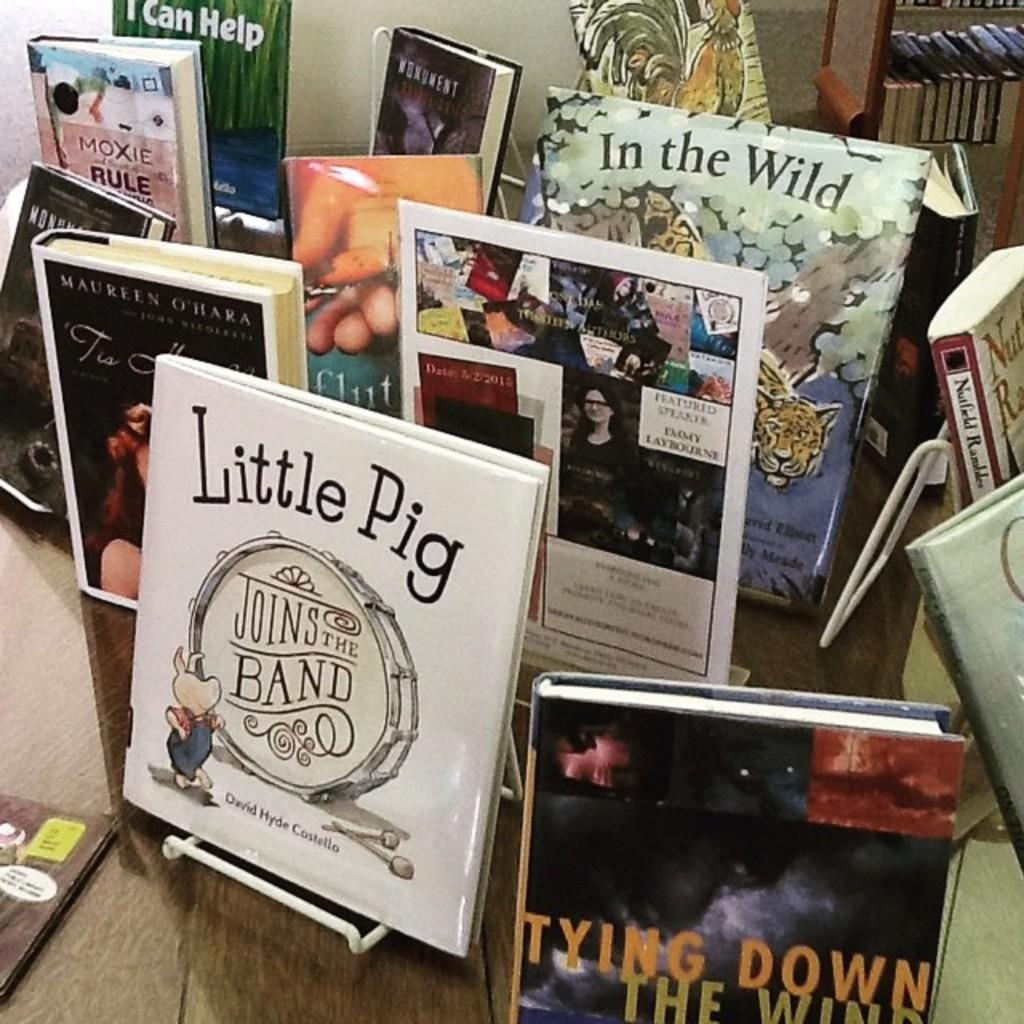Provide a one-sentence caption for the provided image. The bookstore is selling a book titled "Little Pig Joins The Band". 